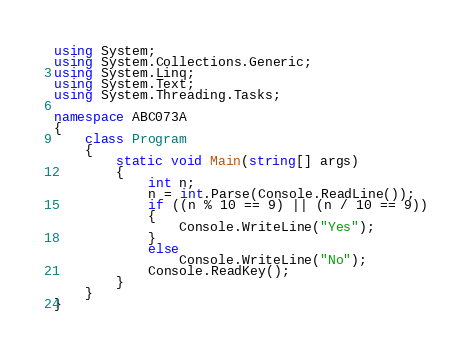<code> <loc_0><loc_0><loc_500><loc_500><_C#_>using System;
using System.Collections.Generic;
using System.Linq;
using System.Text;
using System.Threading.Tasks;

namespace ABC073A
{
    class Program
    {
        static void Main(string[] args)
        {
            int n;
            n = int.Parse(Console.ReadLine());
            if ((n % 10 == 9) || (n / 10 == 9))
            {
                Console.WriteLine("Yes");
            }
            else
                Console.WriteLine("No");
            Console.ReadKey();
        }
    }
}
</code> 